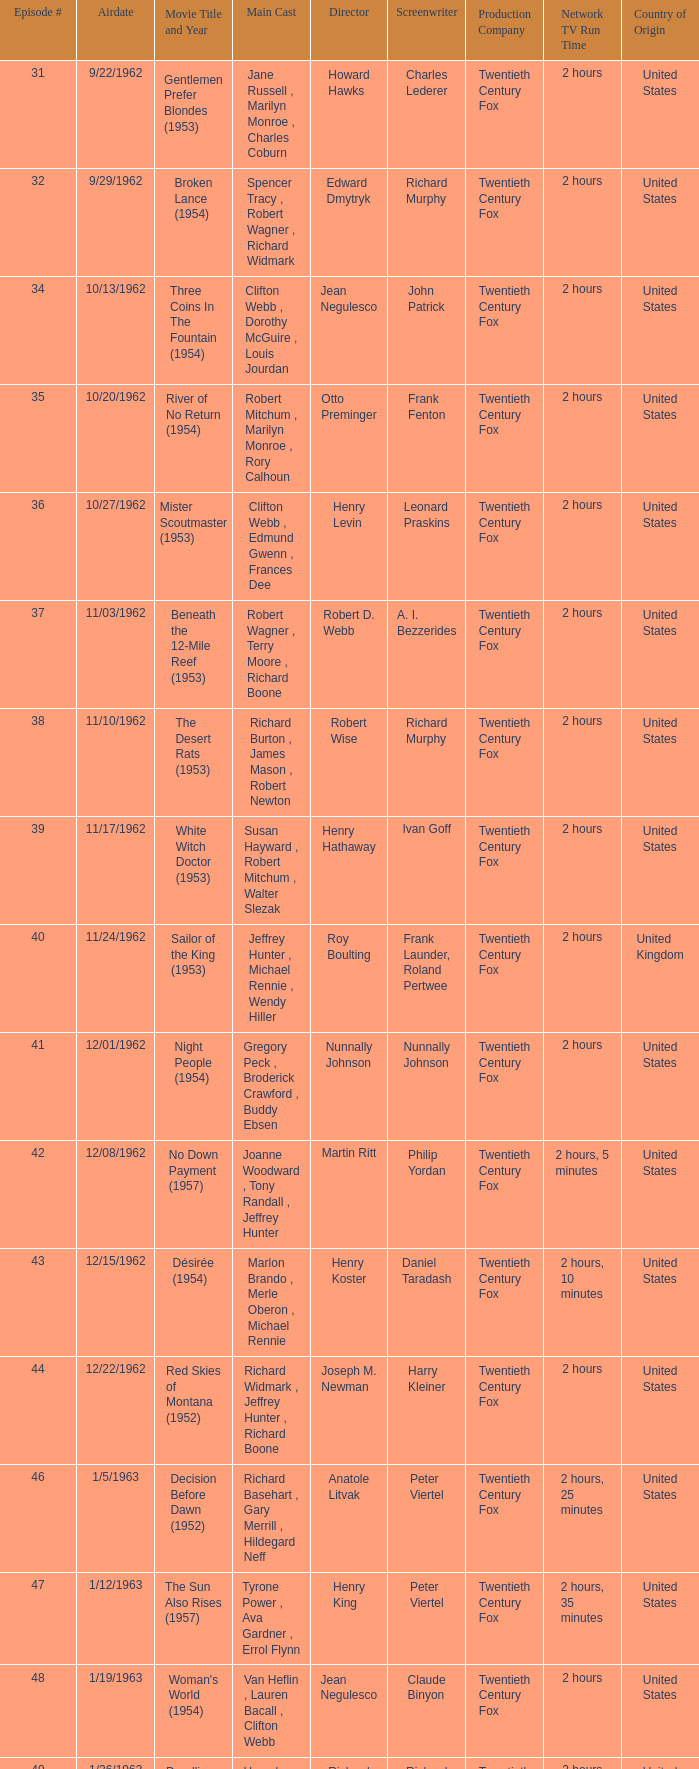Who was the cast on the 3/23/1963 episode? Dana Wynter , Mel Ferrer , Theodore Bikel. Could you parse the entire table? {'header': ['Episode #', 'Airdate', 'Movie Title and Year', 'Main Cast', 'Director', 'Screenwriter', 'Production Company', 'Network TV Run Time', 'Country of Origin'], 'rows': [['31', '9/22/1962', 'Gentlemen Prefer Blondes (1953)', 'Jane Russell , Marilyn Monroe , Charles Coburn', 'Howard Hawks', 'Charles Lederer', 'Twentieth Century Fox', '2 hours', 'United States'], ['32', '9/29/1962', 'Broken Lance (1954)', 'Spencer Tracy , Robert Wagner , Richard Widmark', 'Edward Dmytryk', 'Richard Murphy', 'Twentieth Century Fox', '2 hours', 'United States'], ['34', '10/13/1962', 'Three Coins In The Fountain (1954)', 'Clifton Webb , Dorothy McGuire , Louis Jourdan', 'Jean Negulesco', 'John Patrick', 'Twentieth Century Fox', '2 hours', 'United States'], ['35', '10/20/1962', 'River of No Return (1954)', 'Robert Mitchum , Marilyn Monroe , Rory Calhoun', 'Otto Preminger', 'Frank Fenton', 'Twentieth Century Fox', '2 hours', 'United States'], ['36', '10/27/1962', 'Mister Scoutmaster (1953)', 'Clifton Webb , Edmund Gwenn , Frances Dee', 'Henry Levin', 'Leonard Praskins', 'Twentieth Century Fox', '2 hours', 'United States'], ['37', '11/03/1962', 'Beneath the 12-Mile Reef (1953)', 'Robert Wagner , Terry Moore , Richard Boone', 'Robert D. Webb', 'A. I. Bezzerides', 'Twentieth Century Fox', '2 hours', 'United States'], ['38', '11/10/1962', 'The Desert Rats (1953)', 'Richard Burton , James Mason , Robert Newton', 'Robert Wise', 'Richard Murphy', 'Twentieth Century Fox', '2 hours', 'United States'], ['39', '11/17/1962', 'White Witch Doctor (1953)', 'Susan Hayward , Robert Mitchum , Walter Slezak', 'Henry Hathaway', 'Ivan Goff', 'Twentieth Century Fox', '2 hours', 'United States'], ['40', '11/24/1962', 'Sailor of the King (1953)', 'Jeffrey Hunter , Michael Rennie , Wendy Hiller', 'Roy Boulting', 'Frank Launder, Roland Pertwee', 'Twentieth Century Fox', '2 hours', 'United Kingdom'], ['41', '12/01/1962', 'Night People (1954)', 'Gregory Peck , Broderick Crawford , Buddy Ebsen', 'Nunnally Johnson', 'Nunnally Johnson', 'Twentieth Century Fox', '2 hours', 'United States'], ['42', '12/08/1962', 'No Down Payment (1957)', 'Joanne Woodward , Tony Randall , Jeffrey Hunter', 'Martin Ritt', 'Philip Yordan', 'Twentieth Century Fox', '2 hours, 5 minutes', 'United States'], ['43', '12/15/1962', 'Désirée (1954)', 'Marlon Brando , Merle Oberon , Michael Rennie', 'Henry Koster', 'Daniel Taradash', 'Twentieth Century Fox', '2 hours, 10 minutes', 'United States'], ['44', '12/22/1962', 'Red Skies of Montana (1952)', 'Richard Widmark , Jeffrey Hunter , Richard Boone', 'Joseph M. Newman', 'Harry Kleiner', 'Twentieth Century Fox', '2 hours', 'United States'], ['46', '1/5/1963', 'Decision Before Dawn (1952)', 'Richard Basehart , Gary Merrill , Hildegard Neff', 'Anatole Litvak', 'Peter Viertel', 'Twentieth Century Fox', '2 hours, 25 minutes', 'United States'], ['47', '1/12/1963', 'The Sun Also Rises (1957)', 'Tyrone Power , Ava Gardner , Errol Flynn', 'Henry King', 'Peter Viertel', 'Twentieth Century Fox', '2 hours, 35 minutes', 'United States'], ['48', '1/19/1963', "Woman's World (1954)", 'Van Heflin , Lauren Bacall , Clifton Webb', 'Jean Negulesco', 'Claude Binyon', 'Twentieth Century Fox', '2 hours', 'United States'], ['49', '1/26/1963', 'Deadline - U.S.A. (1952)', 'Humphrey Bogart , Kim Hunter , Ed Begley', 'Richard Brooks', 'Richard Brooks', 'Twentieth Century Fox', '2 hours', 'United States'], ['50', '2/2/1963', 'Niagara (1953)', 'Marilyn Monroe , Joseph Cotten , Jean Peters', 'Henry Hathaway', 'Charles Brackett, Walter Reisch, Richard L. Breen', 'Twentieth Century Fox', '2 hours', 'United States'], ['51', '2/9/1963', 'Kangaroo (1952)', "Maureen O'Hara , Peter Lawford , Richard Boone", 'Lewis Milestone', 'Harry Kleiner', 'Twentieth Century Fox', '2 hours', 'United States'], ['52', '2/16/1963', 'The Long Hot Summer (1958)', 'Paul Newman , Joanne Woodward , Orson Wells', 'Martin Ritt', 'Irving Ravetch, Harriet Frank Jr.', 'Twentieth Century Fox', '2 hours, 15 minutes', 'United States'], ['53', '2/23/1963', "The President's Lady (1953)", 'Susan Hayward , Charlton Heston , John McIntire', 'Henry Levin', 'John Patrick', 'Twentieth Century Fox', '2 hours', 'United States'], ['54', '3/2/1963', 'The Roots of Heaven (1958)', 'Errol Flynn , Juliette Greco , Eddie Albert', 'John Huston', 'Romain Gary, Patrick Leigh Fermor', 'Twentieth Century Fox', '2 hours, 25 minutes', 'United States'], ['55', '3/9/1963', 'In Love and War (1958)', 'Robert Wagner , Hope Lange , Jeffrey Hunter', 'Philip Dunne', 'Henry S. Kesler', 'Twentieth Century Fox', '2 hours, 10 minutes', 'United States'], ['56', '3/16/1963', 'A Certain Smile (1958)', 'Rossano Brazzi , Joan Fontaine , Johnny Mathis', 'Jean Negulesco', 'Jay Dratler', 'Twentieth Century Fox', '2 hours, 5 minutes', 'United States'], ['57', '3/23/1963', 'Fraulein (1958)', 'Dana Wynter , Mel Ferrer , Theodore Bikel', 'Henry Koster', 'Leo Townsend', 'Twentieth Century Fox', '2 hours', 'United States'], ['59', '4/6/1963', 'Night and the City (1950)', 'Richard Widmark , Gene Tierney , Herbert Lom', 'Jules Dassin', 'Jo Eisinger, Jules Dassin', 'Twentieth Century Fox', '2 hours', 'United States']]} 